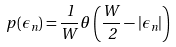<formula> <loc_0><loc_0><loc_500><loc_500>p \left ( \epsilon _ { n } \right ) = \frac { 1 } { W } \theta \left ( \frac { W } { 2 } - \left | \epsilon _ { n } \right | \right )</formula> 